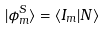<formula> <loc_0><loc_0><loc_500><loc_500>| \phi ^ { S } _ { m } \rangle = \langle I _ { m } | N \rangle</formula> 